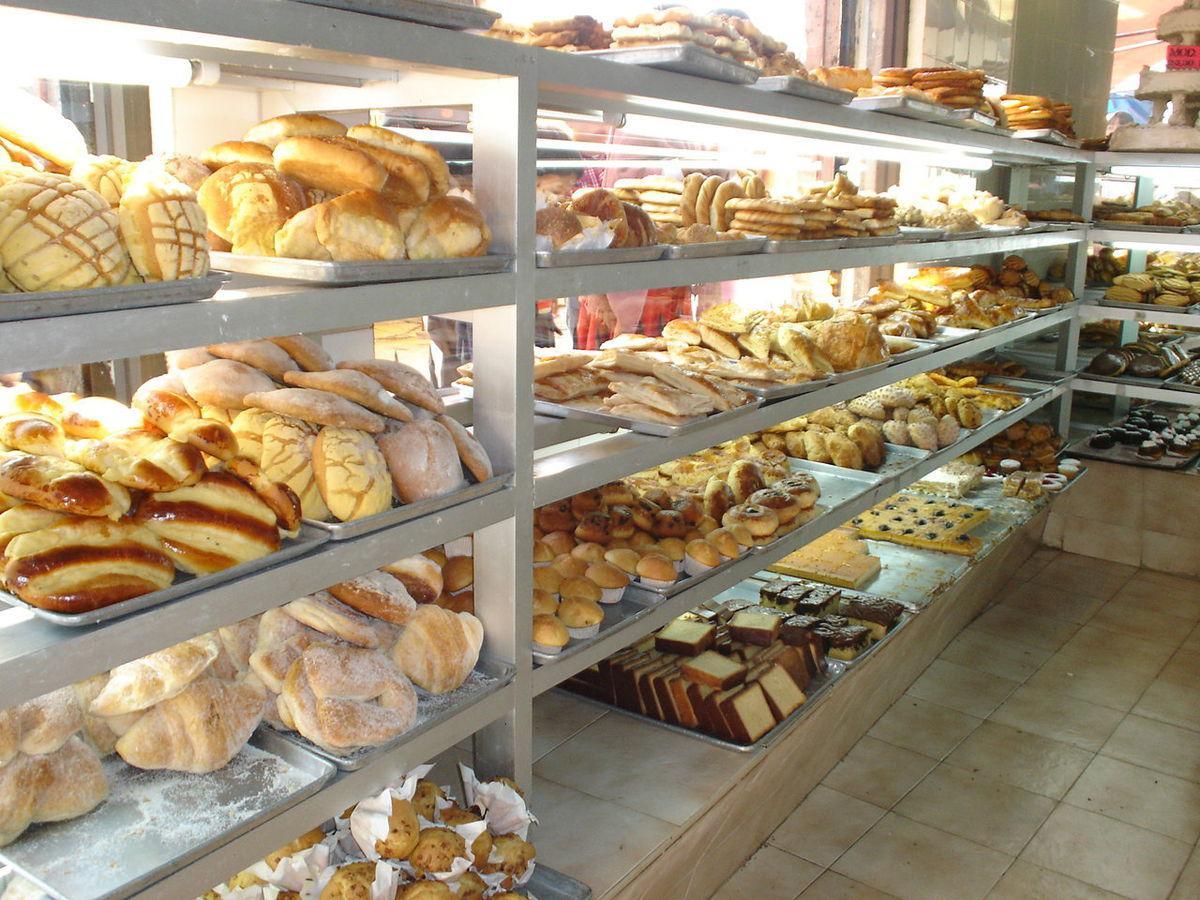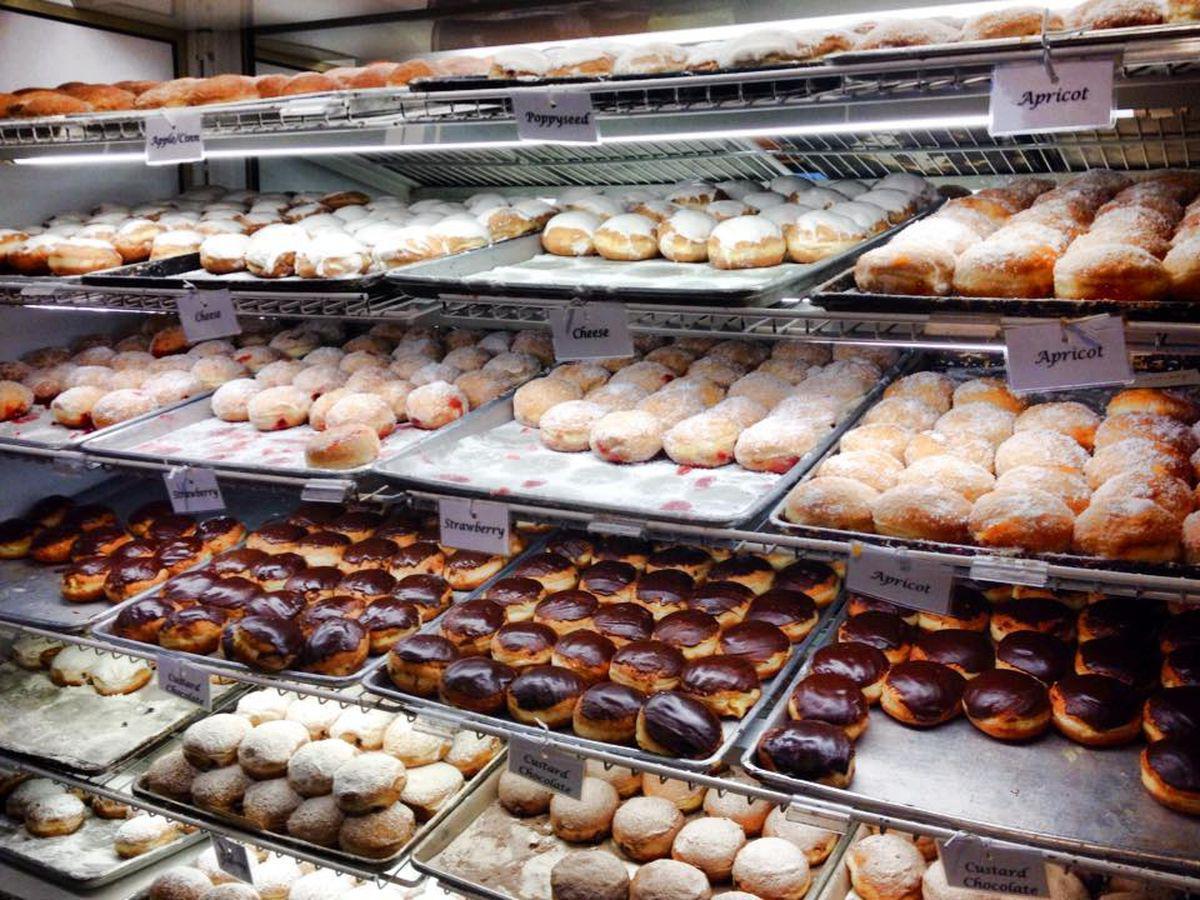The first image is the image on the left, the second image is the image on the right. For the images displayed, is the sentence "One image shows individual stands holding cards in front of bakery items laid out on counter." factually correct? Answer yes or no. No. 